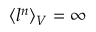<formula> <loc_0><loc_0><loc_500><loc_500>\langle l ^ { n } \rangle _ { V } = \infty</formula> 